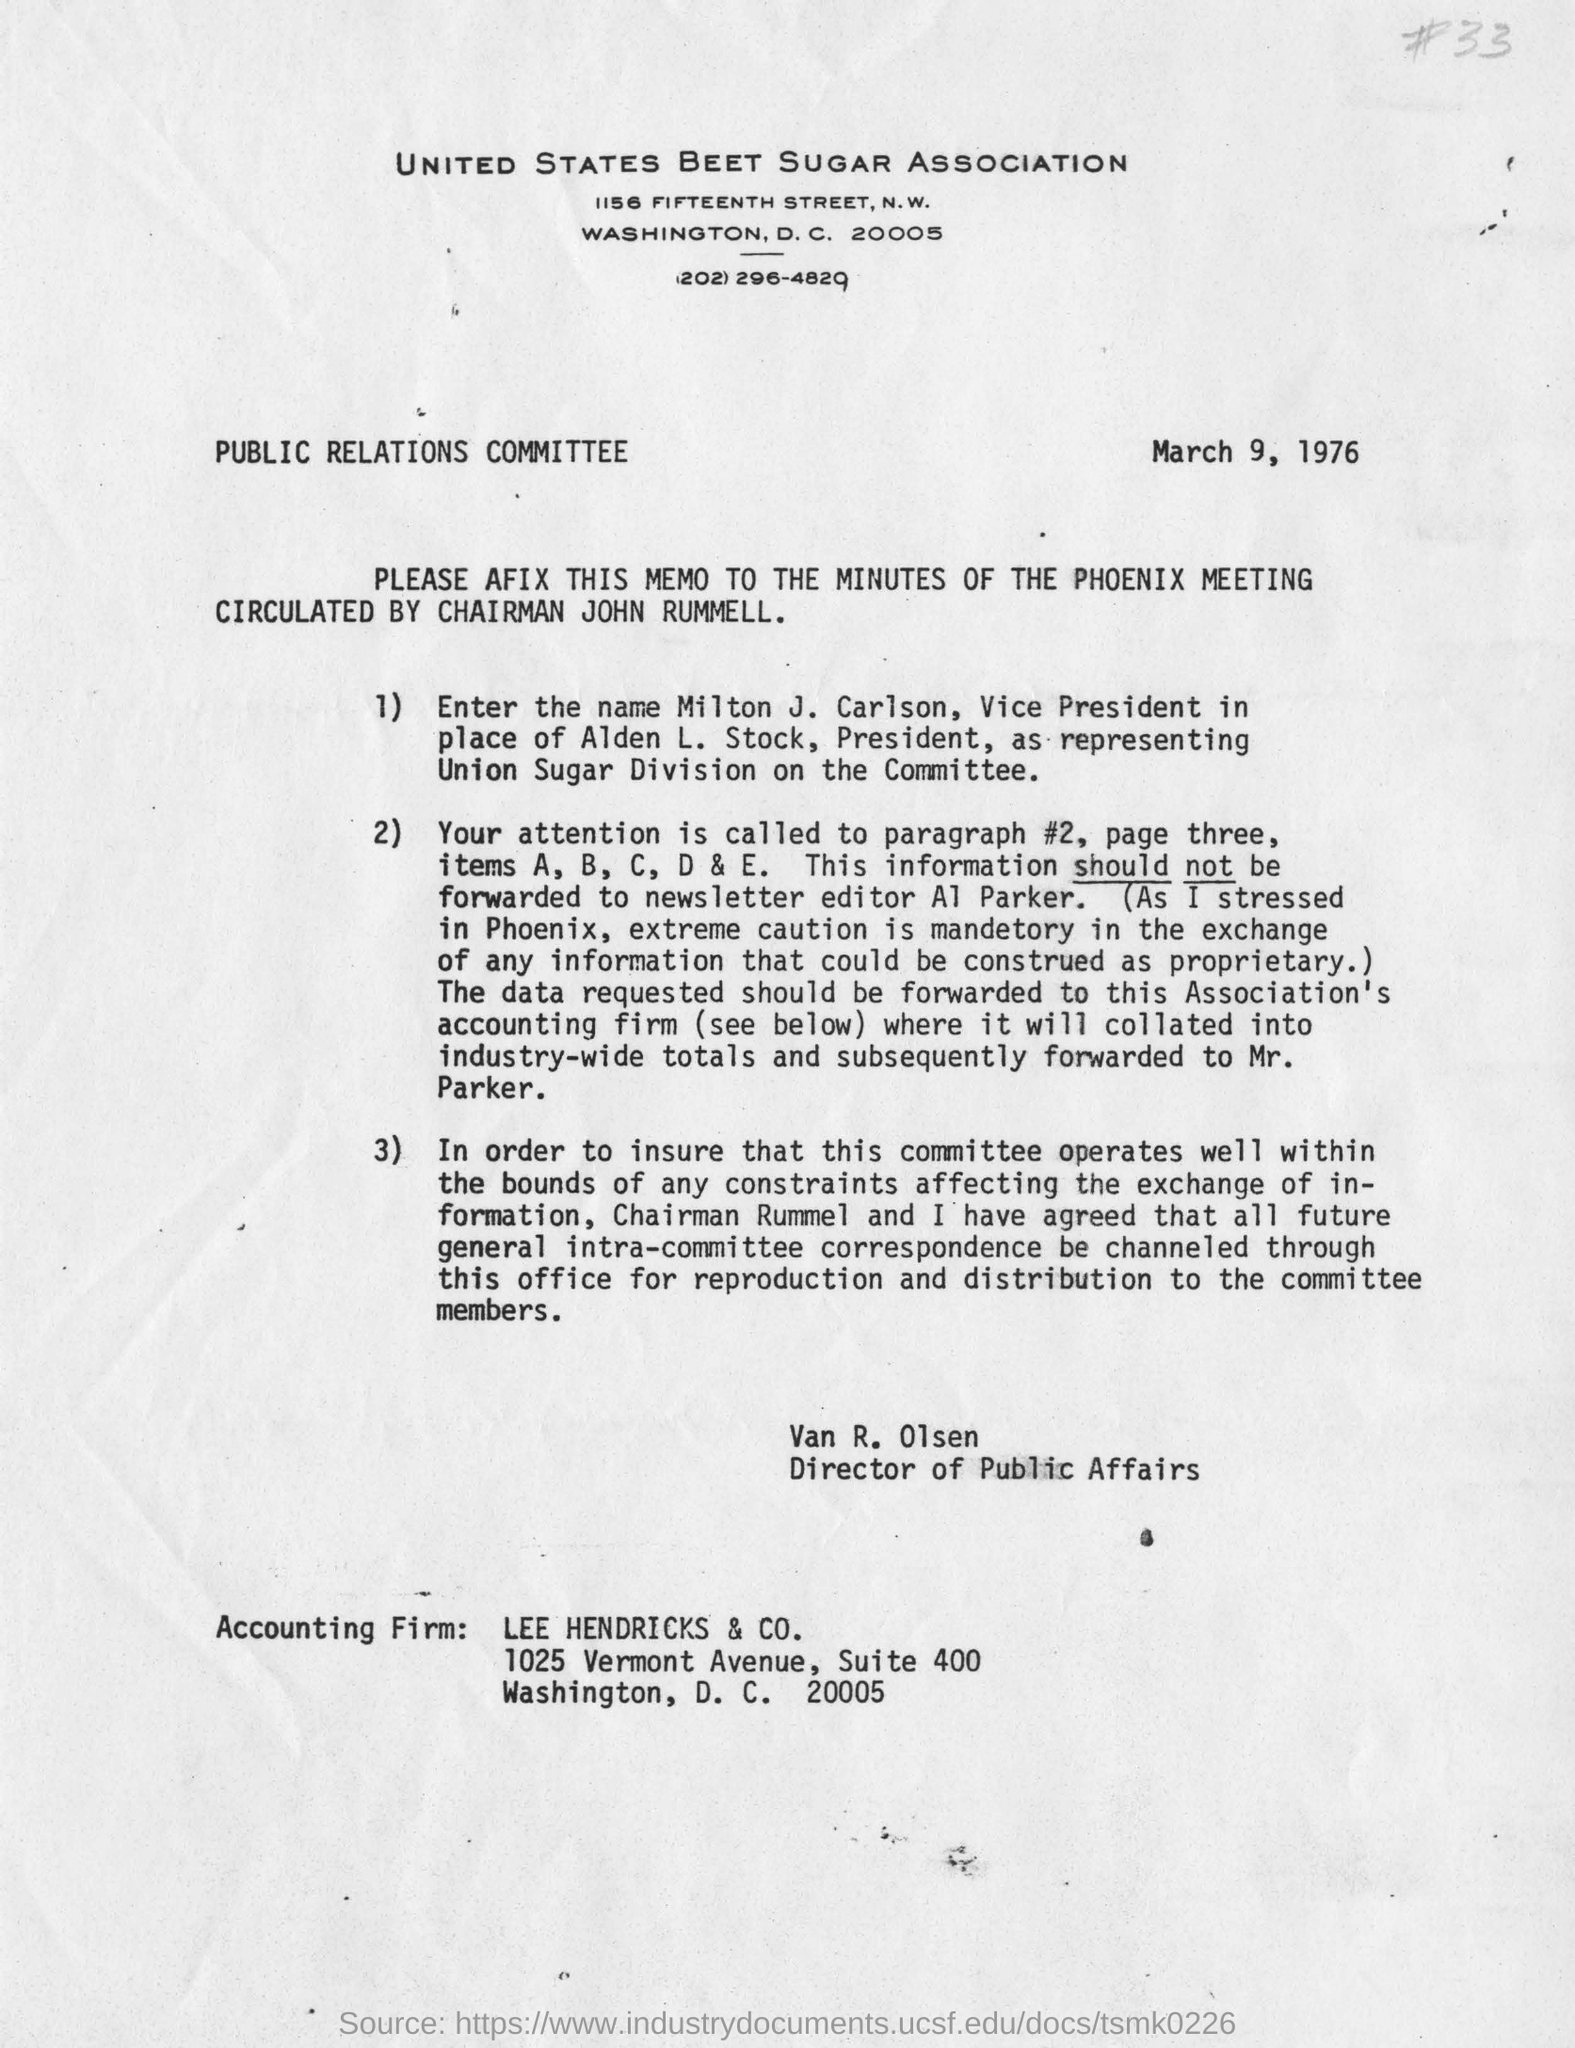What is the name of sugar association?
Give a very brief answer. United states beet sugar association. When is the letter dated on ?
Your answer should be compact. March 9, 1976. Who circulated that to afix the memo to the minutes of the phoenix meeting?
Offer a terse response. Van R. Olsen. Who is vice president in the place of alden l. stock, president ?
Give a very brief answer. Milton J. Carlson. Who is the director of public affairs?
Your answer should be very brief. Van R. Olsen. Which is the accounting firm?
Offer a terse response. LEE HENDRICKS & CO. In which avenue lee Hendricks & CO. is situated?
Make the answer very short. 1025 Vermont Avenue. 